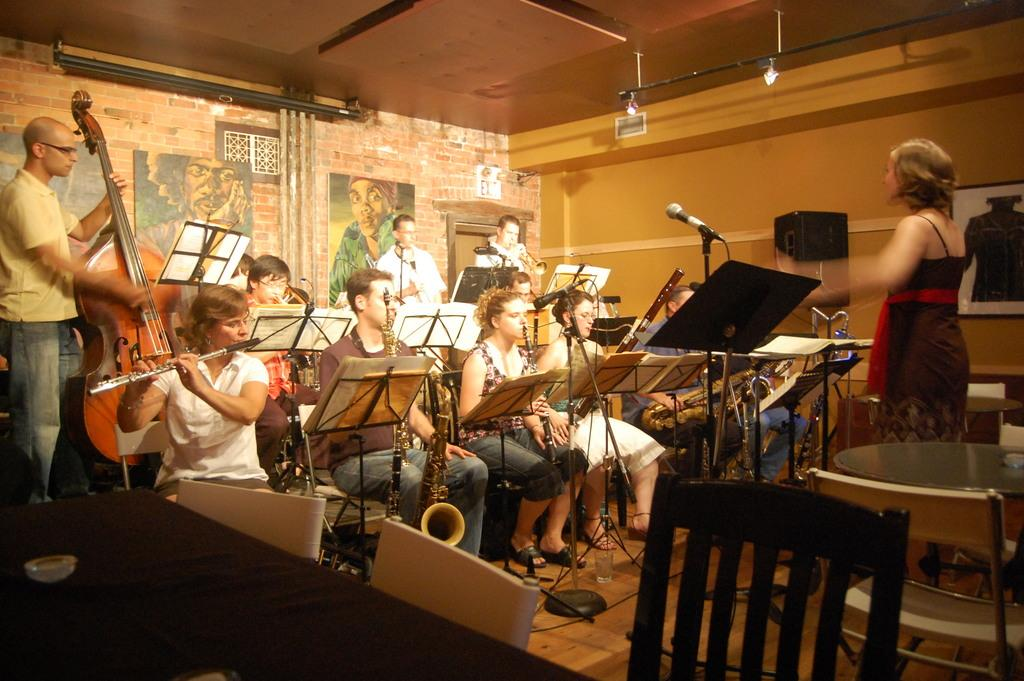What is the main activity being performed by the group of persons in the image? The group of persons is playing music. Can you describe any specific details about the persons in the image? Yes, there is a person wearing a red dress in the image. How many trucks can be seen in the image? There are no trucks present in the image. Is there a patch on the red dress worn by the person in the image? The provided facts do not mention any patch on the red dress, so it cannot be determined from the image. 